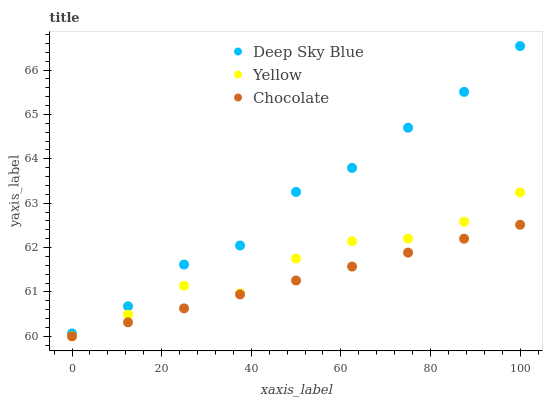Does Chocolate have the minimum area under the curve?
Answer yes or no. Yes. Does Deep Sky Blue have the maximum area under the curve?
Answer yes or no. Yes. Does Deep Sky Blue have the minimum area under the curve?
Answer yes or no. No. Does Chocolate have the maximum area under the curve?
Answer yes or no. No. Is Chocolate the smoothest?
Answer yes or no. Yes. Is Yellow the roughest?
Answer yes or no. Yes. Is Deep Sky Blue the smoothest?
Answer yes or no. No. Is Deep Sky Blue the roughest?
Answer yes or no. No. Does Yellow have the lowest value?
Answer yes or no. Yes. Does Deep Sky Blue have the lowest value?
Answer yes or no. No. Does Deep Sky Blue have the highest value?
Answer yes or no. Yes. Does Chocolate have the highest value?
Answer yes or no. No. Is Yellow less than Deep Sky Blue?
Answer yes or no. Yes. Is Deep Sky Blue greater than Yellow?
Answer yes or no. Yes. Does Yellow intersect Chocolate?
Answer yes or no. Yes. Is Yellow less than Chocolate?
Answer yes or no. No. Is Yellow greater than Chocolate?
Answer yes or no. No. Does Yellow intersect Deep Sky Blue?
Answer yes or no. No. 